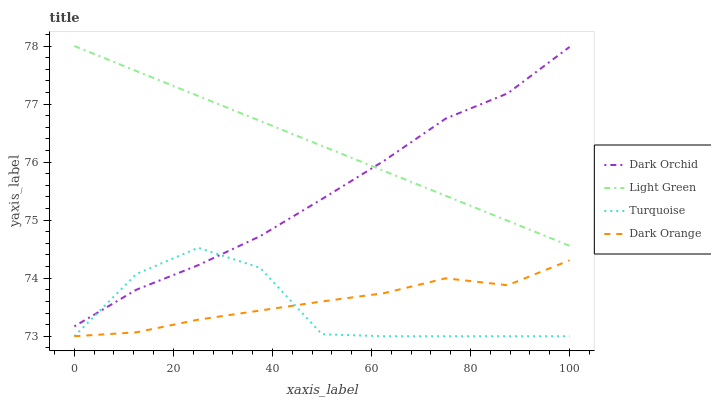Does Turquoise have the minimum area under the curve?
Answer yes or no. Yes. Does Light Green have the maximum area under the curve?
Answer yes or no. Yes. Does Light Green have the minimum area under the curve?
Answer yes or no. No. Does Turquoise have the maximum area under the curve?
Answer yes or no. No. Is Light Green the smoothest?
Answer yes or no. Yes. Is Turquoise the roughest?
Answer yes or no. Yes. Is Turquoise the smoothest?
Answer yes or no. No. Is Light Green the roughest?
Answer yes or no. No. Does Dark Orange have the lowest value?
Answer yes or no. Yes. Does Light Green have the lowest value?
Answer yes or no. No. Does Light Green have the highest value?
Answer yes or no. Yes. Does Turquoise have the highest value?
Answer yes or no. No. Is Turquoise less than Light Green?
Answer yes or no. Yes. Is Dark Orchid greater than Dark Orange?
Answer yes or no. Yes. Does Dark Orange intersect Turquoise?
Answer yes or no. Yes. Is Dark Orange less than Turquoise?
Answer yes or no. No. Is Dark Orange greater than Turquoise?
Answer yes or no. No. Does Turquoise intersect Light Green?
Answer yes or no. No. 